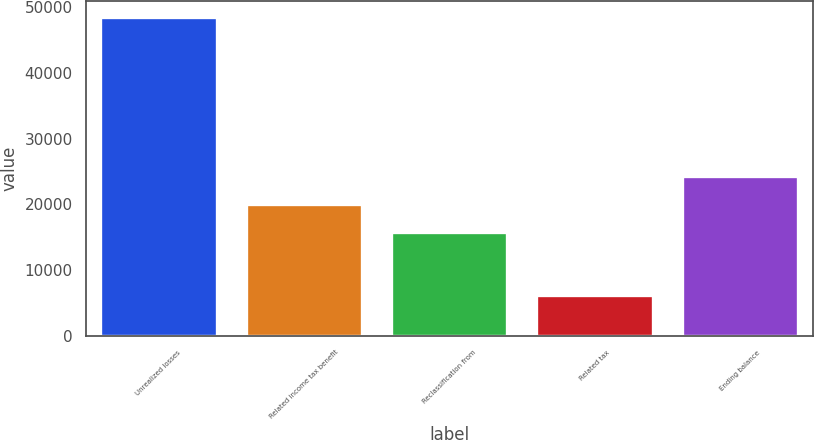Convert chart to OTSL. <chart><loc_0><loc_0><loc_500><loc_500><bar_chart><fcel>Unrealized losses<fcel>Related income tax benefit<fcel>Reclassification from<fcel>Related tax<fcel>Ending balance<nl><fcel>48530<fcel>20055.6<fcel>15818<fcel>6154<fcel>24293.2<nl></chart> 